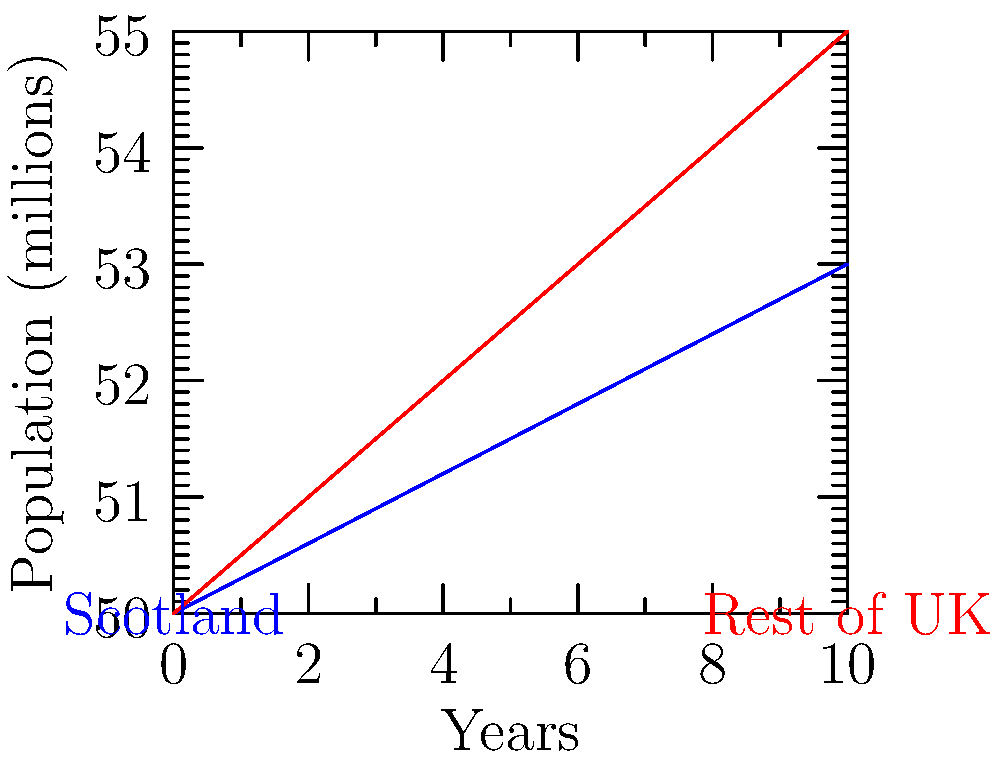Based on the graph showing population growth rates for Scotland and the rest of the UK over a 10-year period, what is the difference in annual population growth rate between Scotland and the rest of the UK? To determine the difference in annual population growth rate:

1. Identify the slope of each line:
   - Scotland (blue line): Rise = 0.3 million per year
   - Rest of UK (red line): Rise = 0.5 million per year

2. The slope represents the annual growth rate for each region.

3. Calculate the difference:
   $\text{Difference} = \text{Rest of UK rate} - \text{Scotland rate}$
   $= 0.5 - 0.3 = 0.2$ million per year

4. Convert to a percentage:
   $0.2 \text{ million} = 200,000 = 0.2\%$ of the population

Therefore, the rest of the UK's population is growing 0.2% faster annually than Scotland's.
Answer: 0.2% 